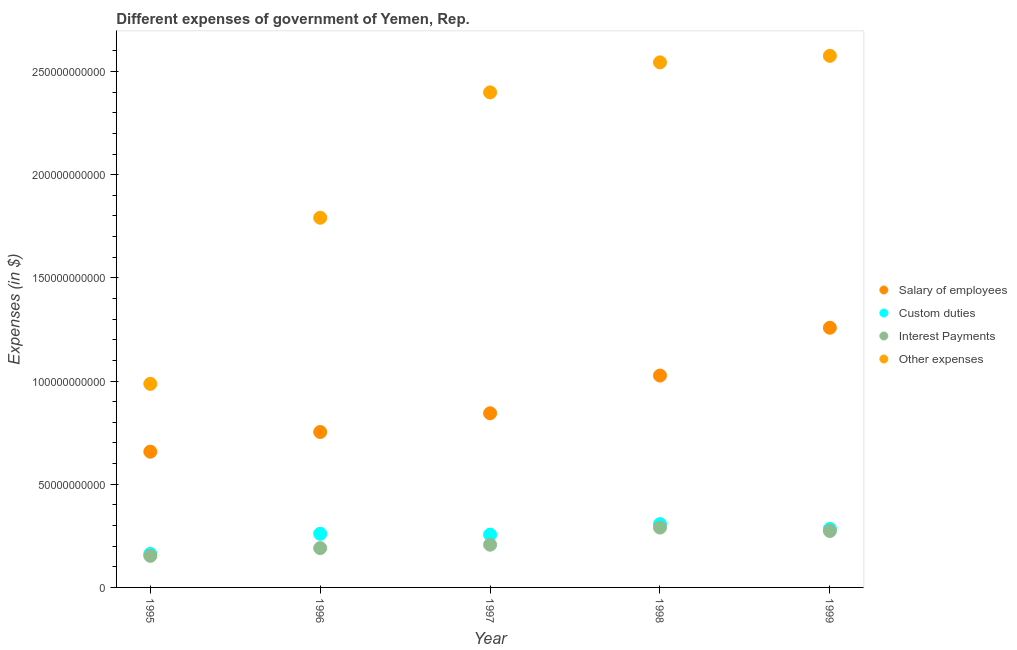Is the number of dotlines equal to the number of legend labels?
Give a very brief answer. Yes. What is the amount spent on salary of employees in 1996?
Provide a short and direct response. 7.53e+1. Across all years, what is the maximum amount spent on custom duties?
Make the answer very short. 3.07e+1. Across all years, what is the minimum amount spent on salary of employees?
Your answer should be compact. 6.58e+1. In which year was the amount spent on other expenses maximum?
Provide a succinct answer. 1999. In which year was the amount spent on interest payments minimum?
Your answer should be very brief. 1995. What is the total amount spent on salary of employees in the graph?
Keep it short and to the point. 4.54e+11. What is the difference between the amount spent on interest payments in 1995 and that in 1996?
Your answer should be very brief. -3.76e+09. What is the difference between the amount spent on custom duties in 1996 and the amount spent on other expenses in 1995?
Offer a terse response. -7.26e+1. What is the average amount spent on interest payments per year?
Your answer should be very brief. 2.23e+1. In the year 1999, what is the difference between the amount spent on other expenses and amount spent on salary of employees?
Give a very brief answer. 1.32e+11. In how many years, is the amount spent on custom duties greater than 90000000000 $?
Ensure brevity in your answer.  0. What is the ratio of the amount spent on custom duties in 1995 to that in 1997?
Make the answer very short. 0.64. Is the amount spent on interest payments in 1995 less than that in 1998?
Your answer should be very brief. Yes. What is the difference between the highest and the second highest amount spent on salary of employees?
Give a very brief answer. 2.32e+1. What is the difference between the highest and the lowest amount spent on custom duties?
Offer a very short reply. 1.44e+1. In how many years, is the amount spent on interest payments greater than the average amount spent on interest payments taken over all years?
Keep it short and to the point. 2. Is the sum of the amount spent on interest payments in 1997 and 1998 greater than the maximum amount spent on custom duties across all years?
Offer a very short reply. Yes. Is it the case that in every year, the sum of the amount spent on interest payments and amount spent on salary of employees is greater than the sum of amount spent on custom duties and amount spent on other expenses?
Your answer should be very brief. Yes. Is it the case that in every year, the sum of the amount spent on salary of employees and amount spent on custom duties is greater than the amount spent on interest payments?
Keep it short and to the point. Yes. Does the amount spent on interest payments monotonically increase over the years?
Ensure brevity in your answer.  No. Is the amount spent on other expenses strictly greater than the amount spent on interest payments over the years?
Keep it short and to the point. Yes. How many dotlines are there?
Your answer should be compact. 4. What is the difference between two consecutive major ticks on the Y-axis?
Make the answer very short. 5.00e+1. Are the values on the major ticks of Y-axis written in scientific E-notation?
Provide a short and direct response. No. Does the graph contain grids?
Give a very brief answer. No. Where does the legend appear in the graph?
Offer a very short reply. Center right. How are the legend labels stacked?
Give a very brief answer. Vertical. What is the title of the graph?
Offer a terse response. Different expenses of government of Yemen, Rep. What is the label or title of the Y-axis?
Provide a succinct answer. Expenses (in $). What is the Expenses (in $) in Salary of employees in 1995?
Provide a short and direct response. 6.58e+1. What is the Expenses (in $) of Custom duties in 1995?
Offer a very short reply. 1.62e+1. What is the Expenses (in $) of Interest Payments in 1995?
Keep it short and to the point. 1.53e+1. What is the Expenses (in $) of Other expenses in 1995?
Provide a succinct answer. 9.86e+1. What is the Expenses (in $) in Salary of employees in 1996?
Provide a short and direct response. 7.53e+1. What is the Expenses (in $) of Custom duties in 1996?
Provide a succinct answer. 2.60e+1. What is the Expenses (in $) of Interest Payments in 1996?
Your answer should be very brief. 1.91e+1. What is the Expenses (in $) of Other expenses in 1996?
Ensure brevity in your answer.  1.79e+11. What is the Expenses (in $) of Salary of employees in 1997?
Offer a terse response. 8.44e+1. What is the Expenses (in $) in Custom duties in 1997?
Your answer should be compact. 2.56e+1. What is the Expenses (in $) of Interest Payments in 1997?
Your answer should be very brief. 2.07e+1. What is the Expenses (in $) of Other expenses in 1997?
Give a very brief answer. 2.40e+11. What is the Expenses (in $) in Salary of employees in 1998?
Your response must be concise. 1.03e+11. What is the Expenses (in $) in Custom duties in 1998?
Your response must be concise. 3.07e+1. What is the Expenses (in $) in Interest Payments in 1998?
Your answer should be compact. 2.90e+1. What is the Expenses (in $) in Other expenses in 1998?
Make the answer very short. 2.54e+11. What is the Expenses (in $) in Salary of employees in 1999?
Make the answer very short. 1.26e+11. What is the Expenses (in $) of Custom duties in 1999?
Keep it short and to the point. 2.83e+1. What is the Expenses (in $) in Interest Payments in 1999?
Give a very brief answer. 2.73e+1. What is the Expenses (in $) in Other expenses in 1999?
Your answer should be very brief. 2.58e+11. Across all years, what is the maximum Expenses (in $) of Salary of employees?
Your answer should be compact. 1.26e+11. Across all years, what is the maximum Expenses (in $) in Custom duties?
Your answer should be compact. 3.07e+1. Across all years, what is the maximum Expenses (in $) in Interest Payments?
Offer a terse response. 2.90e+1. Across all years, what is the maximum Expenses (in $) in Other expenses?
Offer a terse response. 2.58e+11. Across all years, what is the minimum Expenses (in $) of Salary of employees?
Offer a very short reply. 6.58e+1. Across all years, what is the minimum Expenses (in $) of Custom duties?
Give a very brief answer. 1.62e+1. Across all years, what is the minimum Expenses (in $) of Interest Payments?
Provide a succinct answer. 1.53e+1. Across all years, what is the minimum Expenses (in $) in Other expenses?
Your answer should be compact. 9.86e+1. What is the total Expenses (in $) of Salary of employees in the graph?
Offer a terse response. 4.54e+11. What is the total Expenses (in $) in Custom duties in the graph?
Your response must be concise. 1.27e+11. What is the total Expenses (in $) of Interest Payments in the graph?
Your response must be concise. 1.11e+11. What is the total Expenses (in $) in Other expenses in the graph?
Offer a terse response. 1.03e+12. What is the difference between the Expenses (in $) in Salary of employees in 1995 and that in 1996?
Give a very brief answer. -9.55e+09. What is the difference between the Expenses (in $) of Custom duties in 1995 and that in 1996?
Keep it short and to the point. -9.76e+09. What is the difference between the Expenses (in $) of Interest Payments in 1995 and that in 1996?
Your response must be concise. -3.76e+09. What is the difference between the Expenses (in $) of Other expenses in 1995 and that in 1996?
Keep it short and to the point. -8.05e+1. What is the difference between the Expenses (in $) in Salary of employees in 1995 and that in 1997?
Make the answer very short. -1.86e+1. What is the difference between the Expenses (in $) of Custom duties in 1995 and that in 1997?
Provide a short and direct response. -9.32e+09. What is the difference between the Expenses (in $) in Interest Payments in 1995 and that in 1997?
Provide a short and direct response. -5.41e+09. What is the difference between the Expenses (in $) in Other expenses in 1995 and that in 1997?
Make the answer very short. -1.41e+11. What is the difference between the Expenses (in $) in Salary of employees in 1995 and that in 1998?
Your answer should be very brief. -3.69e+1. What is the difference between the Expenses (in $) of Custom duties in 1995 and that in 1998?
Your answer should be compact. -1.44e+1. What is the difference between the Expenses (in $) in Interest Payments in 1995 and that in 1998?
Offer a terse response. -1.37e+1. What is the difference between the Expenses (in $) in Other expenses in 1995 and that in 1998?
Offer a very short reply. -1.56e+11. What is the difference between the Expenses (in $) in Salary of employees in 1995 and that in 1999?
Your response must be concise. -6.01e+1. What is the difference between the Expenses (in $) in Custom duties in 1995 and that in 1999?
Your answer should be compact. -1.21e+1. What is the difference between the Expenses (in $) in Interest Payments in 1995 and that in 1999?
Your response must be concise. -1.20e+1. What is the difference between the Expenses (in $) of Other expenses in 1995 and that in 1999?
Offer a terse response. -1.59e+11. What is the difference between the Expenses (in $) in Salary of employees in 1996 and that in 1997?
Your answer should be very brief. -9.07e+09. What is the difference between the Expenses (in $) in Custom duties in 1996 and that in 1997?
Provide a succinct answer. 4.32e+08. What is the difference between the Expenses (in $) in Interest Payments in 1996 and that in 1997?
Offer a very short reply. -1.65e+09. What is the difference between the Expenses (in $) in Other expenses in 1996 and that in 1997?
Offer a terse response. -6.07e+1. What is the difference between the Expenses (in $) in Salary of employees in 1996 and that in 1998?
Provide a succinct answer. -2.74e+1. What is the difference between the Expenses (in $) of Custom duties in 1996 and that in 1998?
Offer a very short reply. -4.66e+09. What is the difference between the Expenses (in $) of Interest Payments in 1996 and that in 1998?
Give a very brief answer. -9.95e+09. What is the difference between the Expenses (in $) in Other expenses in 1996 and that in 1998?
Provide a short and direct response. -7.53e+1. What is the difference between the Expenses (in $) in Salary of employees in 1996 and that in 1999?
Provide a succinct answer. -5.05e+1. What is the difference between the Expenses (in $) of Custom duties in 1996 and that in 1999?
Provide a succinct answer. -2.35e+09. What is the difference between the Expenses (in $) of Interest Payments in 1996 and that in 1999?
Keep it short and to the point. -8.29e+09. What is the difference between the Expenses (in $) in Other expenses in 1996 and that in 1999?
Provide a short and direct response. -7.85e+1. What is the difference between the Expenses (in $) of Salary of employees in 1997 and that in 1998?
Provide a succinct answer. -1.83e+1. What is the difference between the Expenses (in $) in Custom duties in 1997 and that in 1998?
Provide a short and direct response. -5.09e+09. What is the difference between the Expenses (in $) in Interest Payments in 1997 and that in 1998?
Your answer should be very brief. -8.29e+09. What is the difference between the Expenses (in $) of Other expenses in 1997 and that in 1998?
Your response must be concise. -1.45e+1. What is the difference between the Expenses (in $) in Salary of employees in 1997 and that in 1999?
Provide a short and direct response. -4.15e+1. What is the difference between the Expenses (in $) in Custom duties in 1997 and that in 1999?
Offer a very short reply. -2.78e+09. What is the difference between the Expenses (in $) in Interest Payments in 1997 and that in 1999?
Offer a terse response. -6.63e+09. What is the difference between the Expenses (in $) in Other expenses in 1997 and that in 1999?
Your answer should be compact. -1.77e+1. What is the difference between the Expenses (in $) of Salary of employees in 1998 and that in 1999?
Your response must be concise. -2.32e+1. What is the difference between the Expenses (in $) of Custom duties in 1998 and that in 1999?
Make the answer very short. 2.30e+09. What is the difference between the Expenses (in $) in Interest Payments in 1998 and that in 1999?
Give a very brief answer. 1.66e+09. What is the difference between the Expenses (in $) in Other expenses in 1998 and that in 1999?
Provide a succinct answer. -3.17e+09. What is the difference between the Expenses (in $) of Salary of employees in 1995 and the Expenses (in $) of Custom duties in 1996?
Offer a terse response. 3.98e+1. What is the difference between the Expenses (in $) in Salary of employees in 1995 and the Expenses (in $) in Interest Payments in 1996?
Your response must be concise. 4.67e+1. What is the difference between the Expenses (in $) in Salary of employees in 1995 and the Expenses (in $) in Other expenses in 1996?
Your response must be concise. -1.13e+11. What is the difference between the Expenses (in $) of Custom duties in 1995 and the Expenses (in $) of Interest Payments in 1996?
Offer a terse response. -2.81e+09. What is the difference between the Expenses (in $) in Custom duties in 1995 and the Expenses (in $) in Other expenses in 1996?
Offer a very short reply. -1.63e+11. What is the difference between the Expenses (in $) of Interest Payments in 1995 and the Expenses (in $) of Other expenses in 1996?
Give a very brief answer. -1.64e+11. What is the difference between the Expenses (in $) of Salary of employees in 1995 and the Expenses (in $) of Custom duties in 1997?
Make the answer very short. 4.02e+1. What is the difference between the Expenses (in $) of Salary of employees in 1995 and the Expenses (in $) of Interest Payments in 1997?
Give a very brief answer. 4.51e+1. What is the difference between the Expenses (in $) in Salary of employees in 1995 and the Expenses (in $) in Other expenses in 1997?
Make the answer very short. -1.74e+11. What is the difference between the Expenses (in $) of Custom duties in 1995 and the Expenses (in $) of Interest Payments in 1997?
Provide a succinct answer. -4.47e+09. What is the difference between the Expenses (in $) of Custom duties in 1995 and the Expenses (in $) of Other expenses in 1997?
Your response must be concise. -2.24e+11. What is the difference between the Expenses (in $) of Interest Payments in 1995 and the Expenses (in $) of Other expenses in 1997?
Give a very brief answer. -2.25e+11. What is the difference between the Expenses (in $) in Salary of employees in 1995 and the Expenses (in $) in Custom duties in 1998?
Your answer should be very brief. 3.51e+1. What is the difference between the Expenses (in $) in Salary of employees in 1995 and the Expenses (in $) in Interest Payments in 1998?
Keep it short and to the point. 3.68e+1. What is the difference between the Expenses (in $) of Salary of employees in 1995 and the Expenses (in $) of Other expenses in 1998?
Offer a terse response. -1.89e+11. What is the difference between the Expenses (in $) of Custom duties in 1995 and the Expenses (in $) of Interest Payments in 1998?
Offer a very short reply. -1.28e+1. What is the difference between the Expenses (in $) of Custom duties in 1995 and the Expenses (in $) of Other expenses in 1998?
Give a very brief answer. -2.38e+11. What is the difference between the Expenses (in $) of Interest Payments in 1995 and the Expenses (in $) of Other expenses in 1998?
Provide a short and direct response. -2.39e+11. What is the difference between the Expenses (in $) in Salary of employees in 1995 and the Expenses (in $) in Custom duties in 1999?
Make the answer very short. 3.74e+1. What is the difference between the Expenses (in $) in Salary of employees in 1995 and the Expenses (in $) in Interest Payments in 1999?
Your answer should be very brief. 3.84e+1. What is the difference between the Expenses (in $) in Salary of employees in 1995 and the Expenses (in $) in Other expenses in 1999?
Keep it short and to the point. -1.92e+11. What is the difference between the Expenses (in $) of Custom duties in 1995 and the Expenses (in $) of Interest Payments in 1999?
Provide a short and direct response. -1.11e+1. What is the difference between the Expenses (in $) in Custom duties in 1995 and the Expenses (in $) in Other expenses in 1999?
Ensure brevity in your answer.  -2.41e+11. What is the difference between the Expenses (in $) in Interest Payments in 1995 and the Expenses (in $) in Other expenses in 1999?
Your answer should be compact. -2.42e+11. What is the difference between the Expenses (in $) of Salary of employees in 1996 and the Expenses (in $) of Custom duties in 1997?
Provide a short and direct response. 4.97e+1. What is the difference between the Expenses (in $) in Salary of employees in 1996 and the Expenses (in $) in Interest Payments in 1997?
Your answer should be very brief. 5.46e+1. What is the difference between the Expenses (in $) of Salary of employees in 1996 and the Expenses (in $) of Other expenses in 1997?
Your answer should be compact. -1.65e+11. What is the difference between the Expenses (in $) in Custom duties in 1996 and the Expenses (in $) in Interest Payments in 1997?
Offer a very short reply. 5.29e+09. What is the difference between the Expenses (in $) of Custom duties in 1996 and the Expenses (in $) of Other expenses in 1997?
Your answer should be very brief. -2.14e+11. What is the difference between the Expenses (in $) in Interest Payments in 1996 and the Expenses (in $) in Other expenses in 1997?
Provide a short and direct response. -2.21e+11. What is the difference between the Expenses (in $) in Salary of employees in 1996 and the Expenses (in $) in Custom duties in 1998?
Make the answer very short. 4.47e+1. What is the difference between the Expenses (in $) of Salary of employees in 1996 and the Expenses (in $) of Interest Payments in 1998?
Ensure brevity in your answer.  4.63e+1. What is the difference between the Expenses (in $) of Salary of employees in 1996 and the Expenses (in $) of Other expenses in 1998?
Your answer should be compact. -1.79e+11. What is the difference between the Expenses (in $) of Custom duties in 1996 and the Expenses (in $) of Interest Payments in 1998?
Ensure brevity in your answer.  -3.00e+09. What is the difference between the Expenses (in $) of Custom duties in 1996 and the Expenses (in $) of Other expenses in 1998?
Provide a short and direct response. -2.28e+11. What is the difference between the Expenses (in $) in Interest Payments in 1996 and the Expenses (in $) in Other expenses in 1998?
Make the answer very short. -2.35e+11. What is the difference between the Expenses (in $) of Salary of employees in 1996 and the Expenses (in $) of Custom duties in 1999?
Your answer should be very brief. 4.70e+1. What is the difference between the Expenses (in $) of Salary of employees in 1996 and the Expenses (in $) of Interest Payments in 1999?
Provide a succinct answer. 4.80e+1. What is the difference between the Expenses (in $) in Salary of employees in 1996 and the Expenses (in $) in Other expenses in 1999?
Offer a very short reply. -1.82e+11. What is the difference between the Expenses (in $) in Custom duties in 1996 and the Expenses (in $) in Interest Payments in 1999?
Make the answer very short. -1.34e+09. What is the difference between the Expenses (in $) in Custom duties in 1996 and the Expenses (in $) in Other expenses in 1999?
Offer a terse response. -2.32e+11. What is the difference between the Expenses (in $) in Interest Payments in 1996 and the Expenses (in $) in Other expenses in 1999?
Make the answer very short. -2.39e+11. What is the difference between the Expenses (in $) in Salary of employees in 1997 and the Expenses (in $) in Custom duties in 1998?
Your answer should be very brief. 5.37e+1. What is the difference between the Expenses (in $) in Salary of employees in 1997 and the Expenses (in $) in Interest Payments in 1998?
Keep it short and to the point. 5.54e+1. What is the difference between the Expenses (in $) of Salary of employees in 1997 and the Expenses (in $) of Other expenses in 1998?
Offer a very short reply. -1.70e+11. What is the difference between the Expenses (in $) of Custom duties in 1997 and the Expenses (in $) of Interest Payments in 1998?
Offer a terse response. -3.44e+09. What is the difference between the Expenses (in $) in Custom duties in 1997 and the Expenses (in $) in Other expenses in 1998?
Provide a short and direct response. -2.29e+11. What is the difference between the Expenses (in $) in Interest Payments in 1997 and the Expenses (in $) in Other expenses in 1998?
Keep it short and to the point. -2.34e+11. What is the difference between the Expenses (in $) of Salary of employees in 1997 and the Expenses (in $) of Custom duties in 1999?
Provide a succinct answer. 5.60e+1. What is the difference between the Expenses (in $) of Salary of employees in 1997 and the Expenses (in $) of Interest Payments in 1999?
Provide a short and direct response. 5.70e+1. What is the difference between the Expenses (in $) in Salary of employees in 1997 and the Expenses (in $) in Other expenses in 1999?
Make the answer very short. -1.73e+11. What is the difference between the Expenses (in $) of Custom duties in 1997 and the Expenses (in $) of Interest Payments in 1999?
Offer a very short reply. -1.77e+09. What is the difference between the Expenses (in $) in Custom duties in 1997 and the Expenses (in $) in Other expenses in 1999?
Your answer should be very brief. -2.32e+11. What is the difference between the Expenses (in $) of Interest Payments in 1997 and the Expenses (in $) of Other expenses in 1999?
Your answer should be compact. -2.37e+11. What is the difference between the Expenses (in $) of Salary of employees in 1998 and the Expenses (in $) of Custom duties in 1999?
Make the answer very short. 7.43e+1. What is the difference between the Expenses (in $) of Salary of employees in 1998 and the Expenses (in $) of Interest Payments in 1999?
Provide a succinct answer. 7.53e+1. What is the difference between the Expenses (in $) in Salary of employees in 1998 and the Expenses (in $) in Other expenses in 1999?
Provide a short and direct response. -1.55e+11. What is the difference between the Expenses (in $) in Custom duties in 1998 and the Expenses (in $) in Interest Payments in 1999?
Make the answer very short. 3.31e+09. What is the difference between the Expenses (in $) of Custom duties in 1998 and the Expenses (in $) of Other expenses in 1999?
Your answer should be very brief. -2.27e+11. What is the difference between the Expenses (in $) of Interest Payments in 1998 and the Expenses (in $) of Other expenses in 1999?
Ensure brevity in your answer.  -2.29e+11. What is the average Expenses (in $) of Salary of employees per year?
Offer a terse response. 9.08e+1. What is the average Expenses (in $) of Custom duties per year?
Offer a terse response. 2.54e+1. What is the average Expenses (in $) of Interest Payments per year?
Your response must be concise. 2.23e+1. What is the average Expenses (in $) in Other expenses per year?
Your response must be concise. 2.06e+11. In the year 1995, what is the difference between the Expenses (in $) in Salary of employees and Expenses (in $) in Custom duties?
Provide a short and direct response. 4.95e+1. In the year 1995, what is the difference between the Expenses (in $) in Salary of employees and Expenses (in $) in Interest Payments?
Offer a very short reply. 5.05e+1. In the year 1995, what is the difference between the Expenses (in $) in Salary of employees and Expenses (in $) in Other expenses?
Offer a terse response. -3.29e+1. In the year 1995, what is the difference between the Expenses (in $) in Custom duties and Expenses (in $) in Interest Payments?
Offer a very short reply. 9.43e+08. In the year 1995, what is the difference between the Expenses (in $) of Custom duties and Expenses (in $) of Other expenses?
Give a very brief answer. -8.24e+1. In the year 1995, what is the difference between the Expenses (in $) in Interest Payments and Expenses (in $) in Other expenses?
Ensure brevity in your answer.  -8.33e+1. In the year 1996, what is the difference between the Expenses (in $) in Salary of employees and Expenses (in $) in Custom duties?
Your response must be concise. 4.93e+1. In the year 1996, what is the difference between the Expenses (in $) of Salary of employees and Expenses (in $) of Interest Payments?
Your answer should be compact. 5.63e+1. In the year 1996, what is the difference between the Expenses (in $) of Salary of employees and Expenses (in $) of Other expenses?
Your answer should be very brief. -1.04e+11. In the year 1996, what is the difference between the Expenses (in $) of Custom duties and Expenses (in $) of Interest Payments?
Your response must be concise. 6.94e+09. In the year 1996, what is the difference between the Expenses (in $) in Custom duties and Expenses (in $) in Other expenses?
Your response must be concise. -1.53e+11. In the year 1996, what is the difference between the Expenses (in $) of Interest Payments and Expenses (in $) of Other expenses?
Give a very brief answer. -1.60e+11. In the year 1997, what is the difference between the Expenses (in $) in Salary of employees and Expenses (in $) in Custom duties?
Your answer should be very brief. 5.88e+1. In the year 1997, what is the difference between the Expenses (in $) of Salary of employees and Expenses (in $) of Interest Payments?
Your answer should be compact. 6.37e+1. In the year 1997, what is the difference between the Expenses (in $) of Salary of employees and Expenses (in $) of Other expenses?
Provide a short and direct response. -1.55e+11. In the year 1997, what is the difference between the Expenses (in $) in Custom duties and Expenses (in $) in Interest Payments?
Give a very brief answer. 4.86e+09. In the year 1997, what is the difference between the Expenses (in $) of Custom duties and Expenses (in $) of Other expenses?
Ensure brevity in your answer.  -2.14e+11. In the year 1997, what is the difference between the Expenses (in $) of Interest Payments and Expenses (in $) of Other expenses?
Provide a succinct answer. -2.19e+11. In the year 1998, what is the difference between the Expenses (in $) in Salary of employees and Expenses (in $) in Custom duties?
Your response must be concise. 7.20e+1. In the year 1998, what is the difference between the Expenses (in $) of Salary of employees and Expenses (in $) of Interest Payments?
Ensure brevity in your answer.  7.37e+1. In the year 1998, what is the difference between the Expenses (in $) in Salary of employees and Expenses (in $) in Other expenses?
Offer a very short reply. -1.52e+11. In the year 1998, what is the difference between the Expenses (in $) of Custom duties and Expenses (in $) of Interest Payments?
Ensure brevity in your answer.  1.65e+09. In the year 1998, what is the difference between the Expenses (in $) in Custom duties and Expenses (in $) in Other expenses?
Provide a short and direct response. -2.24e+11. In the year 1998, what is the difference between the Expenses (in $) of Interest Payments and Expenses (in $) of Other expenses?
Provide a succinct answer. -2.25e+11. In the year 1999, what is the difference between the Expenses (in $) in Salary of employees and Expenses (in $) in Custom duties?
Offer a terse response. 9.75e+1. In the year 1999, what is the difference between the Expenses (in $) of Salary of employees and Expenses (in $) of Interest Payments?
Make the answer very short. 9.85e+1. In the year 1999, what is the difference between the Expenses (in $) of Salary of employees and Expenses (in $) of Other expenses?
Offer a terse response. -1.32e+11. In the year 1999, what is the difference between the Expenses (in $) in Custom duties and Expenses (in $) in Interest Payments?
Your answer should be very brief. 1.01e+09. In the year 1999, what is the difference between the Expenses (in $) in Custom duties and Expenses (in $) in Other expenses?
Your answer should be very brief. -2.29e+11. In the year 1999, what is the difference between the Expenses (in $) in Interest Payments and Expenses (in $) in Other expenses?
Your answer should be very brief. -2.30e+11. What is the ratio of the Expenses (in $) of Salary of employees in 1995 to that in 1996?
Your response must be concise. 0.87. What is the ratio of the Expenses (in $) in Custom duties in 1995 to that in 1996?
Your response must be concise. 0.62. What is the ratio of the Expenses (in $) in Interest Payments in 1995 to that in 1996?
Your answer should be compact. 0.8. What is the ratio of the Expenses (in $) of Other expenses in 1995 to that in 1996?
Offer a very short reply. 0.55. What is the ratio of the Expenses (in $) in Salary of employees in 1995 to that in 1997?
Ensure brevity in your answer.  0.78. What is the ratio of the Expenses (in $) of Custom duties in 1995 to that in 1997?
Ensure brevity in your answer.  0.64. What is the ratio of the Expenses (in $) of Interest Payments in 1995 to that in 1997?
Offer a very short reply. 0.74. What is the ratio of the Expenses (in $) of Other expenses in 1995 to that in 1997?
Give a very brief answer. 0.41. What is the ratio of the Expenses (in $) of Salary of employees in 1995 to that in 1998?
Ensure brevity in your answer.  0.64. What is the ratio of the Expenses (in $) of Custom duties in 1995 to that in 1998?
Make the answer very short. 0.53. What is the ratio of the Expenses (in $) of Interest Payments in 1995 to that in 1998?
Provide a short and direct response. 0.53. What is the ratio of the Expenses (in $) of Other expenses in 1995 to that in 1998?
Your answer should be compact. 0.39. What is the ratio of the Expenses (in $) in Salary of employees in 1995 to that in 1999?
Make the answer very short. 0.52. What is the ratio of the Expenses (in $) in Custom duties in 1995 to that in 1999?
Ensure brevity in your answer.  0.57. What is the ratio of the Expenses (in $) of Interest Payments in 1995 to that in 1999?
Your answer should be compact. 0.56. What is the ratio of the Expenses (in $) of Other expenses in 1995 to that in 1999?
Your answer should be compact. 0.38. What is the ratio of the Expenses (in $) of Salary of employees in 1996 to that in 1997?
Offer a very short reply. 0.89. What is the ratio of the Expenses (in $) in Custom duties in 1996 to that in 1997?
Provide a succinct answer. 1.02. What is the ratio of the Expenses (in $) in Interest Payments in 1996 to that in 1997?
Your answer should be compact. 0.92. What is the ratio of the Expenses (in $) of Other expenses in 1996 to that in 1997?
Your response must be concise. 0.75. What is the ratio of the Expenses (in $) in Salary of employees in 1996 to that in 1998?
Provide a short and direct response. 0.73. What is the ratio of the Expenses (in $) in Custom duties in 1996 to that in 1998?
Provide a succinct answer. 0.85. What is the ratio of the Expenses (in $) in Interest Payments in 1996 to that in 1998?
Make the answer very short. 0.66. What is the ratio of the Expenses (in $) in Other expenses in 1996 to that in 1998?
Your response must be concise. 0.7. What is the ratio of the Expenses (in $) in Salary of employees in 1996 to that in 1999?
Your answer should be very brief. 0.6. What is the ratio of the Expenses (in $) of Custom duties in 1996 to that in 1999?
Ensure brevity in your answer.  0.92. What is the ratio of the Expenses (in $) in Interest Payments in 1996 to that in 1999?
Provide a short and direct response. 0.7. What is the ratio of the Expenses (in $) in Other expenses in 1996 to that in 1999?
Your answer should be compact. 0.7. What is the ratio of the Expenses (in $) in Salary of employees in 1997 to that in 1998?
Your answer should be compact. 0.82. What is the ratio of the Expenses (in $) in Custom duties in 1997 to that in 1998?
Your answer should be compact. 0.83. What is the ratio of the Expenses (in $) in Interest Payments in 1997 to that in 1998?
Give a very brief answer. 0.71. What is the ratio of the Expenses (in $) of Other expenses in 1997 to that in 1998?
Make the answer very short. 0.94. What is the ratio of the Expenses (in $) of Salary of employees in 1997 to that in 1999?
Offer a very short reply. 0.67. What is the ratio of the Expenses (in $) of Custom duties in 1997 to that in 1999?
Give a very brief answer. 0.9. What is the ratio of the Expenses (in $) in Interest Payments in 1997 to that in 1999?
Your response must be concise. 0.76. What is the ratio of the Expenses (in $) in Other expenses in 1997 to that in 1999?
Make the answer very short. 0.93. What is the ratio of the Expenses (in $) of Salary of employees in 1998 to that in 1999?
Your answer should be very brief. 0.82. What is the ratio of the Expenses (in $) in Custom duties in 1998 to that in 1999?
Your answer should be compact. 1.08. What is the ratio of the Expenses (in $) in Interest Payments in 1998 to that in 1999?
Give a very brief answer. 1.06. What is the ratio of the Expenses (in $) in Other expenses in 1998 to that in 1999?
Keep it short and to the point. 0.99. What is the difference between the highest and the second highest Expenses (in $) of Salary of employees?
Provide a short and direct response. 2.32e+1. What is the difference between the highest and the second highest Expenses (in $) in Custom duties?
Ensure brevity in your answer.  2.30e+09. What is the difference between the highest and the second highest Expenses (in $) in Interest Payments?
Offer a very short reply. 1.66e+09. What is the difference between the highest and the second highest Expenses (in $) of Other expenses?
Ensure brevity in your answer.  3.17e+09. What is the difference between the highest and the lowest Expenses (in $) in Salary of employees?
Keep it short and to the point. 6.01e+1. What is the difference between the highest and the lowest Expenses (in $) of Custom duties?
Ensure brevity in your answer.  1.44e+1. What is the difference between the highest and the lowest Expenses (in $) of Interest Payments?
Your response must be concise. 1.37e+1. What is the difference between the highest and the lowest Expenses (in $) of Other expenses?
Give a very brief answer. 1.59e+11. 